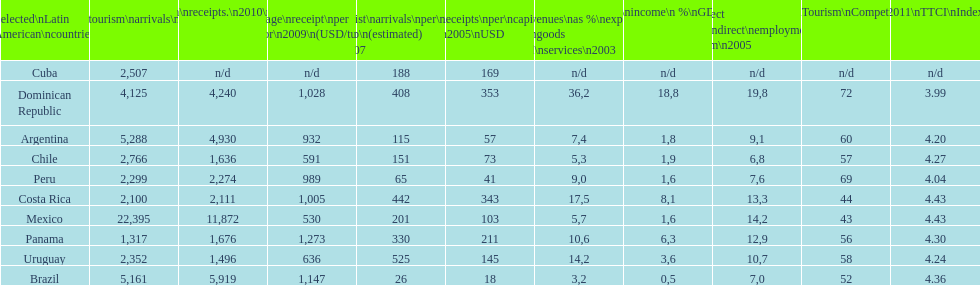What country ranks the best in most categories? Dominican Republic. 